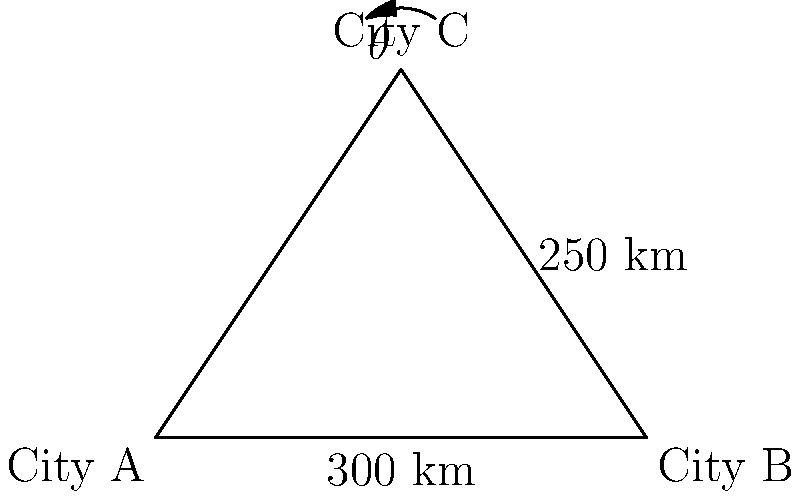As a demographer studying migration patterns, you're analyzing the movement between three cities: A, B, and C. The distance between cities A and B is 300 km, and between B and C is 250 km. The angle at city C (θ) is 53°. Using the law of sines, calculate the distance between cities A and C to the nearest kilometer. How might this information be useful in predicting future population distribution? Let's approach this step-by-step using the law of sines:

1) The law of sines states that in a triangle ABC:

   $$\frac{a}{\sin A} = \frac{b}{\sin B} = \frac{c}{\sin C}$$

   where a, b, and c are the lengths of the sides opposite to angles A, B, and C respectively.

2) In our case, we know:
   - Side c (AB) = 300 km
   - Side a (BC) = 250 km
   - Angle C (θ) = 53°

3) We need to find side b (AC). Let's call the angle at A as α. We can use:

   $$\frac{250}{\sin 53°} = \frac{b}{\sin \alpha}$$

4) We don't know α, but we know that in a triangle, all angles sum to 180°. If we can find angle B (β), we can calculate α:

   $$\alpha + 53° + \beta = 180°$$
   $$\alpha = 127° - \beta$$

5) Now we can use the law of sines again:

   $$\frac{300}{\sin 53°} = \frac{250}{\sin \beta}$$

6) Solving for β:

   $$\sin \beta = \frac{250 \sin 53°}{300} \approx 0.6631$$
   $$\beta \approx 41.54°$$

7) Now we can calculate α:

   $$\alpha = 127° - 41.54° = 85.46°$$

8) Finally, we can solve for b:

   $$\frac{250}{\sin 53°} = \frac{b}{\sin 85.46°}$$
   $$b = \frac{250 \sin 85.46°}{\sin 53°} \approx 280.9 \text{ km}$$

Rounding to the nearest kilometer, the distance between cities A and C is 281 km.

This information is crucial for predicting future population distribution as it helps in understanding the accessibility between cities. Shorter distances might lead to increased migration and commuting, potentially resulting in suburban growth or the formation of megalopolises. It can also inform infrastructure planning, such as high-speed rail connections or highway expansions, which in turn influence long-term population trends.
Answer: 281 km 